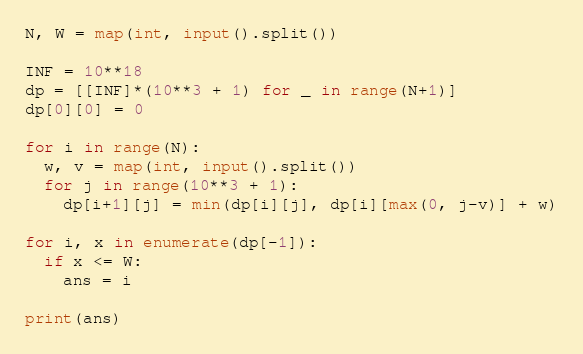Convert code to text. <code><loc_0><loc_0><loc_500><loc_500><_Python_>N, W = map(int, input().split())

INF = 10**18
dp = [[INF]*(10**3 + 1) for _ in range(N+1)]
dp[0][0] = 0

for i in range(N):
  w, v = map(int, input().split())
  for j in range(10**3 + 1):
    dp[i+1][j] = min(dp[i][j], dp[i][max(0, j-v)] + w)

for i, x in enumerate(dp[-1]):
  if x <= W:
    ans = i

print(ans)</code> 